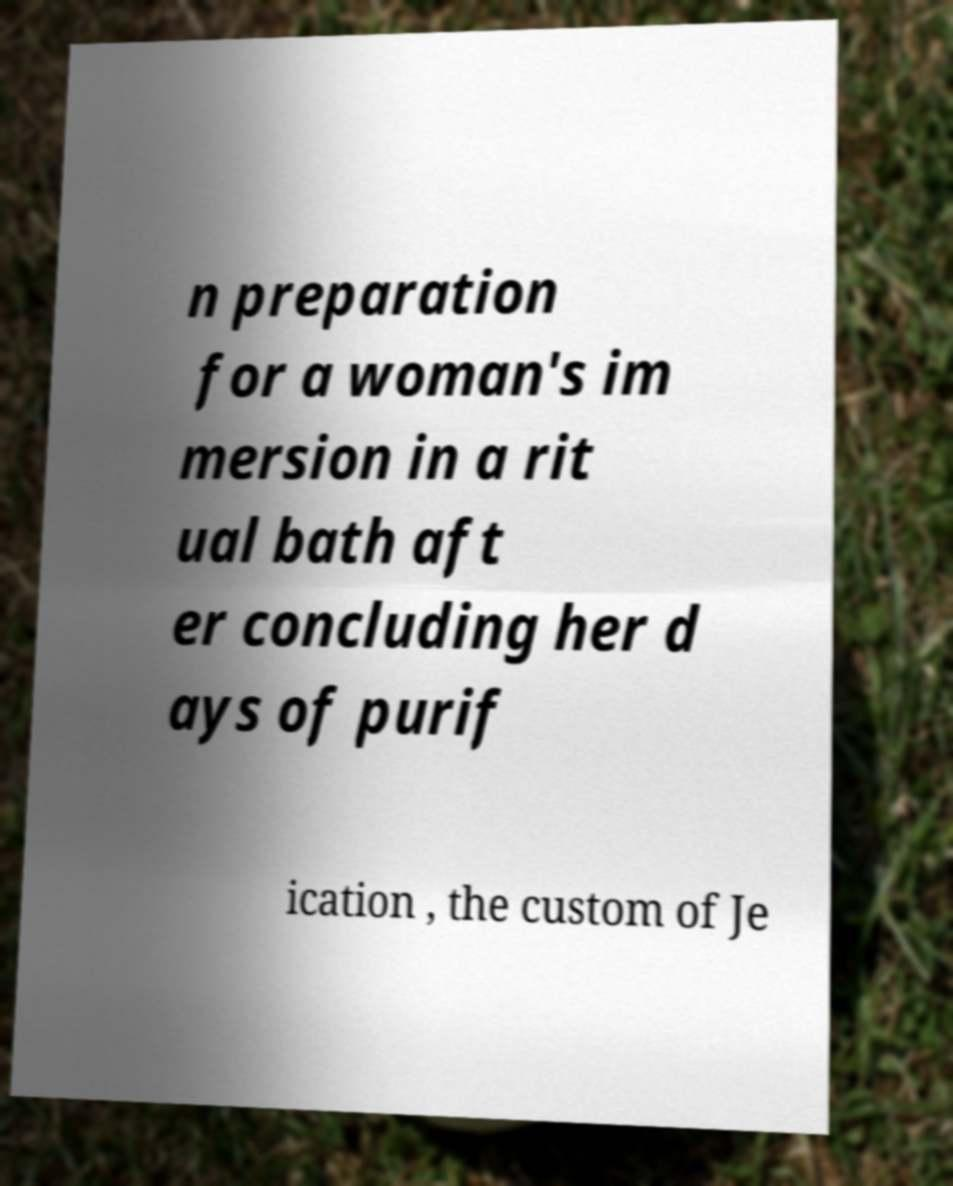Could you extract and type out the text from this image? n preparation for a woman's im mersion in a rit ual bath aft er concluding her d ays of purif ication , the custom of Je 